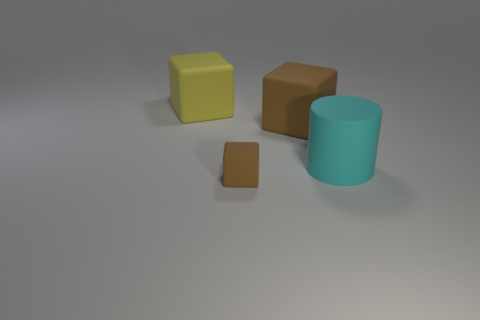Add 4 big objects. How many objects exist? 8 Subtract 1 cylinders. How many cylinders are left? 0 Add 1 large brown rubber cubes. How many large brown rubber cubes are left? 2 Add 4 small green objects. How many small green objects exist? 4 Subtract all brown blocks. How many blocks are left? 1 Subtract all small matte blocks. How many blocks are left? 2 Subtract 0 green cylinders. How many objects are left? 4 Subtract all cylinders. How many objects are left? 3 Subtract all brown cubes. Subtract all red balls. How many cubes are left? 1 Subtract all blue cylinders. How many brown cubes are left? 2 